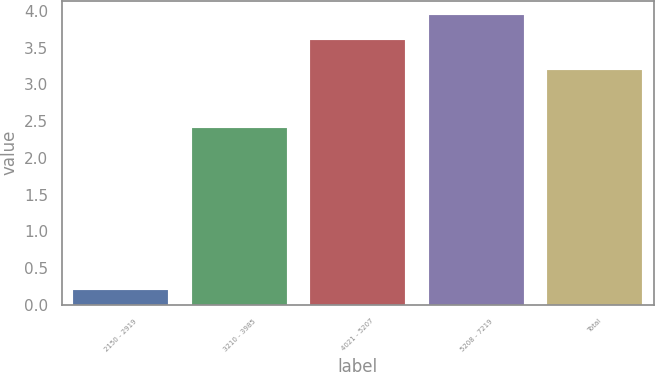Convert chart. <chart><loc_0><loc_0><loc_500><loc_500><bar_chart><fcel>2150 - 2919<fcel>3210 - 3985<fcel>4021 - 5207<fcel>5208 - 7219<fcel>Total<nl><fcel>0.2<fcel>2.4<fcel>3.6<fcel>3.94<fcel>3.2<nl></chart> 